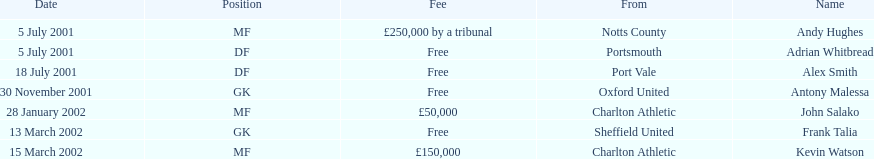Which transfer in was next after john salako's in 2002? Frank Talia. 